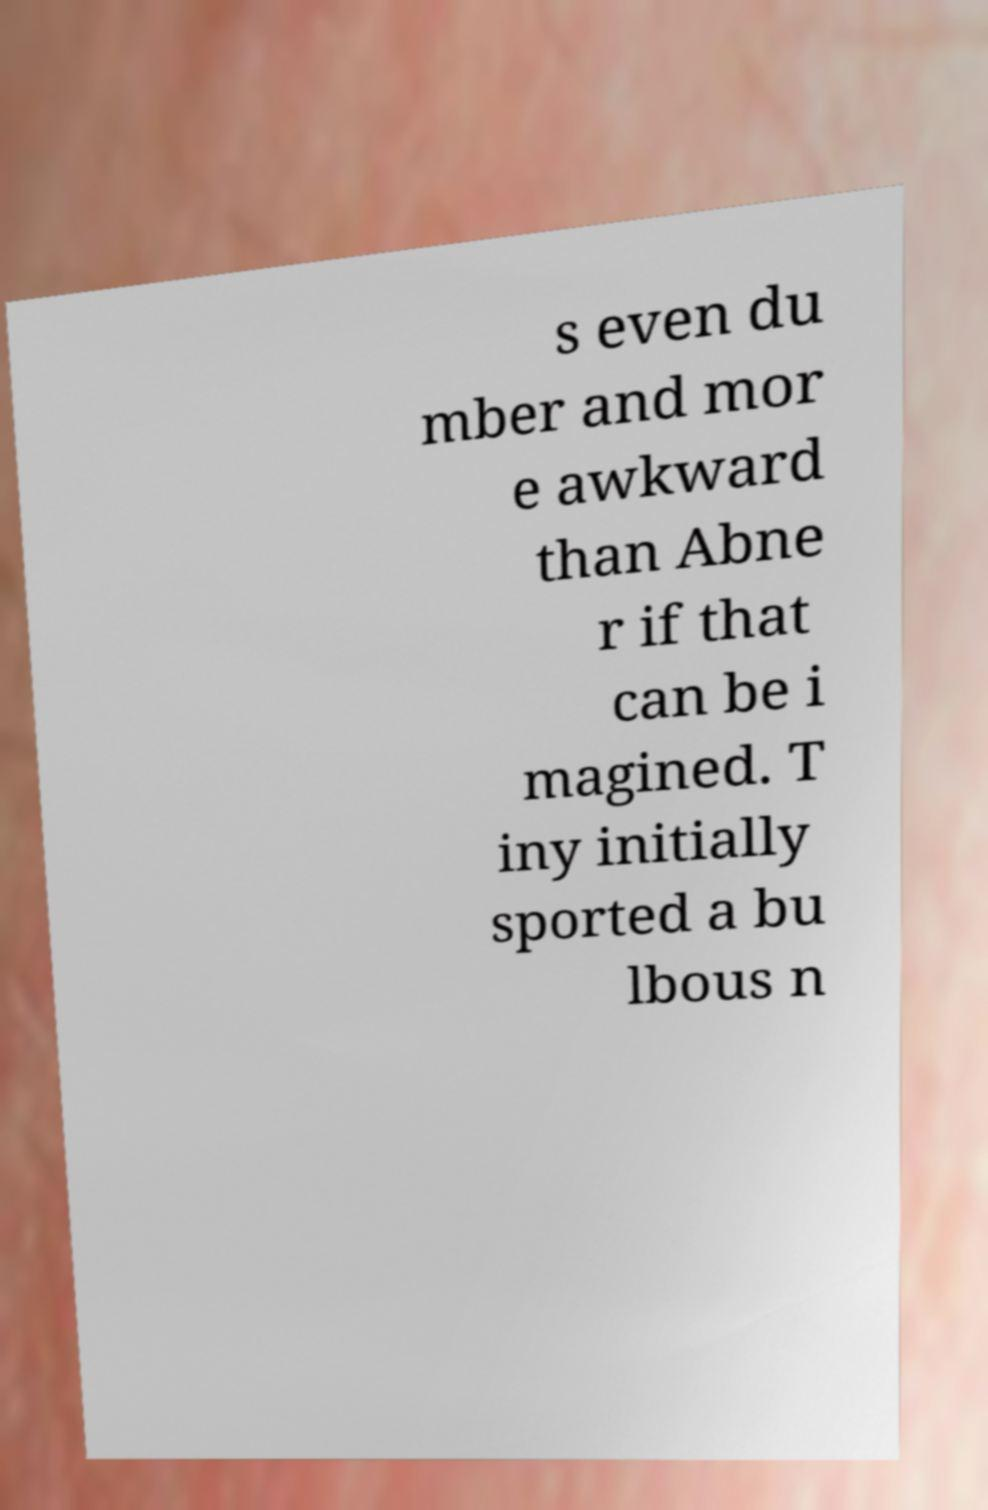What messages or text are displayed in this image? I need them in a readable, typed format. s even du mber and mor e awkward than Abne r if that can be i magined. T iny initially sported a bu lbous n 